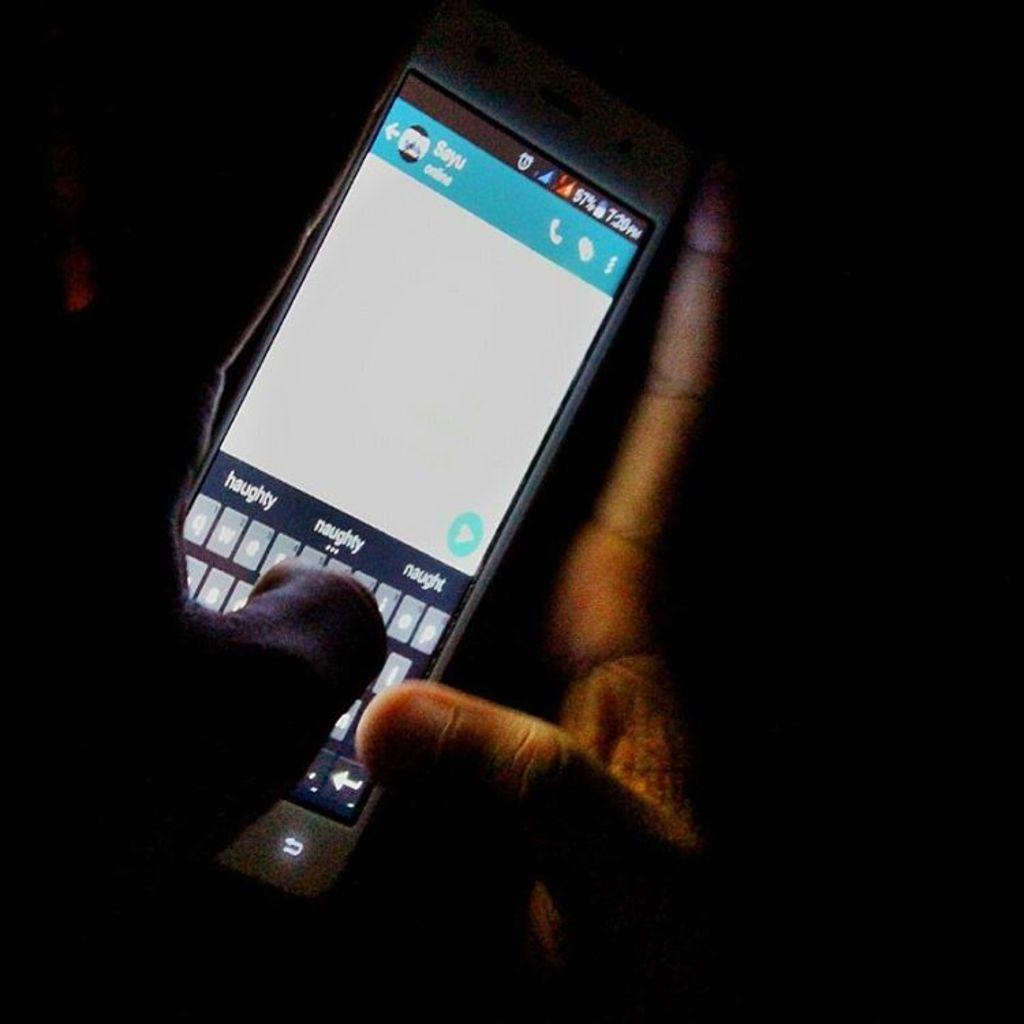<image>
Describe the image concisely. Darkly shadowed hands are texting on a smartphone that is displaying the suggested words haughty, naughty and naught. 